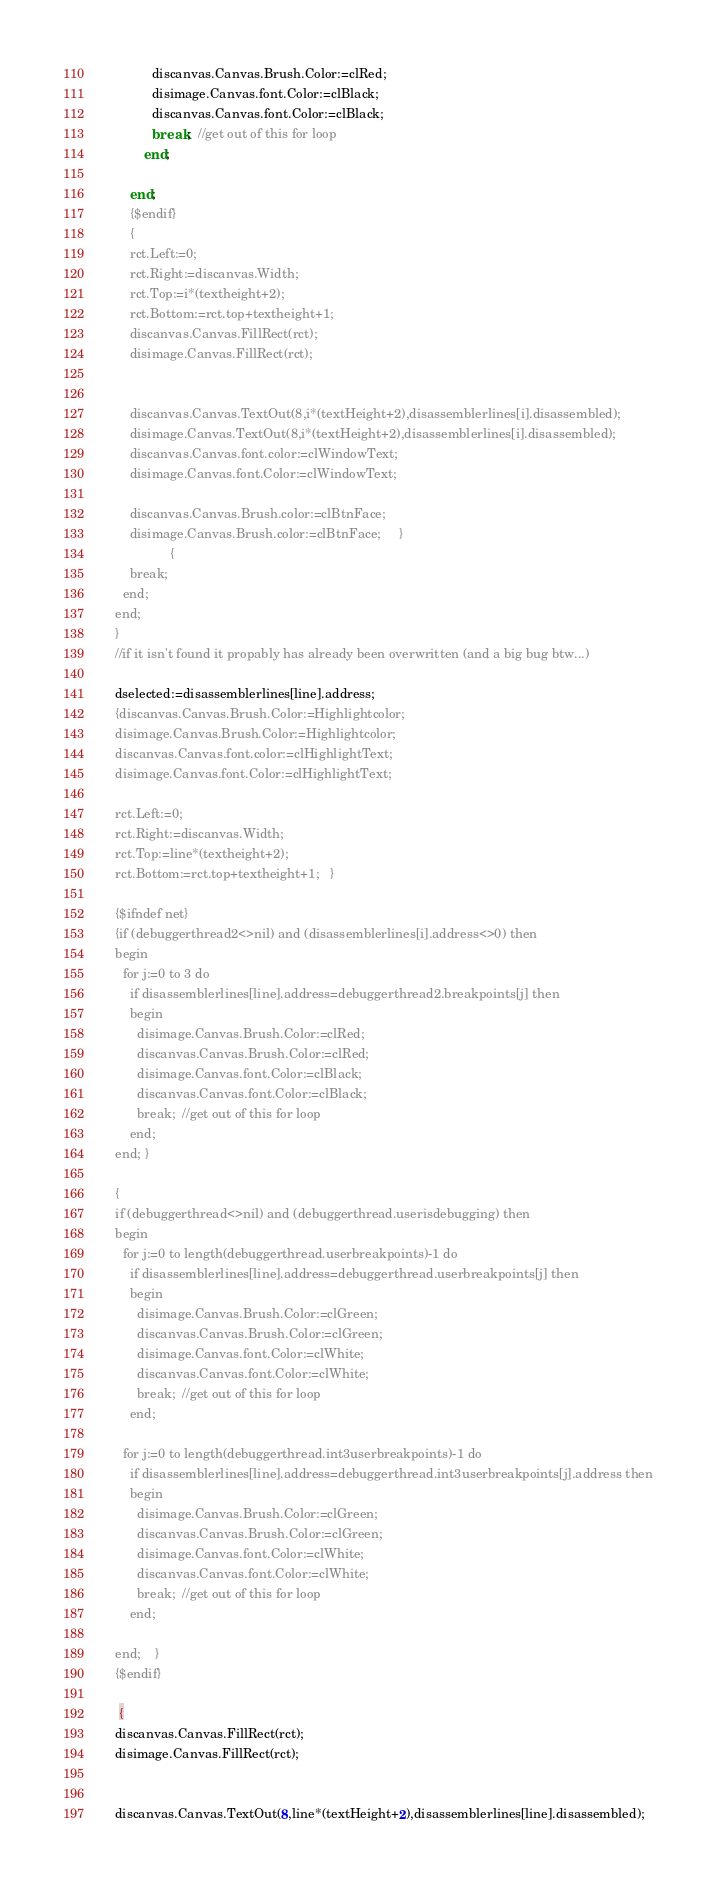Convert code to text. <code><loc_0><loc_0><loc_500><loc_500><_Pascal_>              discanvas.Canvas.Brush.Color:=clRed;
              disimage.Canvas.font.Color:=clBlack;
              discanvas.Canvas.font.Color:=clBlack;
              break;  //get out of this for loop
            end;

        end;
        {$endif}
        {
        rct.Left:=0;
        rct.Right:=discanvas.Width;
        rct.Top:=i*(textheight+2);
        rct.Bottom:=rct.top+textheight+1;
        discanvas.Canvas.FillRect(rct);
        disimage.Canvas.FillRect(rct);


        discanvas.Canvas.TextOut(8,i*(textHeight+2),disassemblerlines[i].disassembled);
        disimage.Canvas.TextOut(8,i*(textHeight+2),disassemblerlines[i].disassembled);
        discanvas.Canvas.font.color:=clWindowText;
        disimage.Canvas.font.Color:=clWindowText;

        discanvas.Canvas.Brush.color:=clBtnFace;
        disimage.Canvas.Brush.color:=clBtnFace;     }
                   {
        break;
      end;
    end;
    }
    //if it isn't found it propably has already been overwritten (and a big bug btw...)

    dselected:=disassemblerlines[line].address;
    {discanvas.Canvas.Brush.Color:=Highlightcolor;
    disimage.Canvas.Brush.Color:=Highlightcolor;
    discanvas.Canvas.font.color:=clHighlightText;
    disimage.Canvas.font.Color:=clHighlightText;

    rct.Left:=0;
    rct.Right:=discanvas.Width;
    rct.Top:=line*(textheight+2);
    rct.Bottom:=rct.top+textheight+1;   }

    {$ifndef net}
    {if (debuggerthread2<>nil) and (disassemblerlines[i].address<>0) then
    begin
      for j:=0 to 3 do
        if disassemblerlines[line].address=debuggerthread2.breakpoints[j] then
        begin
          disimage.Canvas.Brush.Color:=clRed;
          discanvas.Canvas.Brush.Color:=clRed;
          disimage.Canvas.font.Color:=clBlack;
          discanvas.Canvas.font.Color:=clBlack;
          break;  //get out of this for loop
        end;
    end; }

    {
    if (debuggerthread<>nil) and (debuggerthread.userisdebugging) then
    begin
      for j:=0 to length(debuggerthread.userbreakpoints)-1 do
        if disassemblerlines[line].address=debuggerthread.userbreakpoints[j] then
        begin
          disimage.Canvas.Brush.Color:=clGreen;
          discanvas.Canvas.Brush.Color:=clGreen;
          disimage.Canvas.font.Color:=clWhite;
          discanvas.Canvas.font.Color:=clWhite;
          break;  //get out of this for loop
        end;

      for j:=0 to length(debuggerthread.int3userbreakpoints)-1 do
        if disassemblerlines[line].address=debuggerthread.int3userbreakpoints[j].address then
        begin
          disimage.Canvas.Brush.Color:=clGreen;
          discanvas.Canvas.Brush.Color:=clGreen;
          disimage.Canvas.font.Color:=clWhite;
          discanvas.Canvas.font.Color:=clWhite;
          break;  //get out of this for loop
        end;

    end;    }
    {$endif}

     {
    discanvas.Canvas.FillRect(rct);
    disimage.Canvas.FillRect(rct);


    discanvas.Canvas.TextOut(8,line*(textHeight+2),disassemblerlines[line].disassembled);</code> 